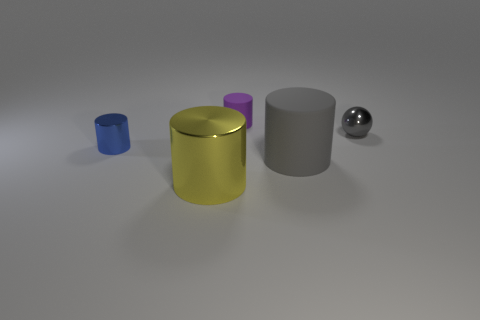What number of balls are either gray rubber objects or big yellow metal things?
Your answer should be very brief. 0. There is a thing that is the same color as the small ball; what is its size?
Provide a short and direct response. Large. Is the number of purple things that are in front of the yellow cylinder less than the number of purple matte spheres?
Give a very brief answer. No. What is the color of the metallic thing that is to the left of the small gray metallic thing and right of the small blue thing?
Provide a succinct answer. Yellow. What number of other objects are the same shape as the purple matte object?
Your answer should be compact. 3. Are there fewer big yellow cylinders that are behind the small gray metallic object than yellow objects that are behind the large rubber cylinder?
Your answer should be very brief. No. Do the large yellow cylinder and the tiny object that is to the right of the large matte cylinder have the same material?
Provide a short and direct response. Yes. Are there any other things that have the same material as the yellow thing?
Provide a short and direct response. Yes. Are there more tiny gray objects than green rubber blocks?
Make the answer very short. Yes. There is a small metallic object behind the metallic cylinder that is behind the shiny object that is in front of the big matte object; what shape is it?
Give a very brief answer. Sphere. 